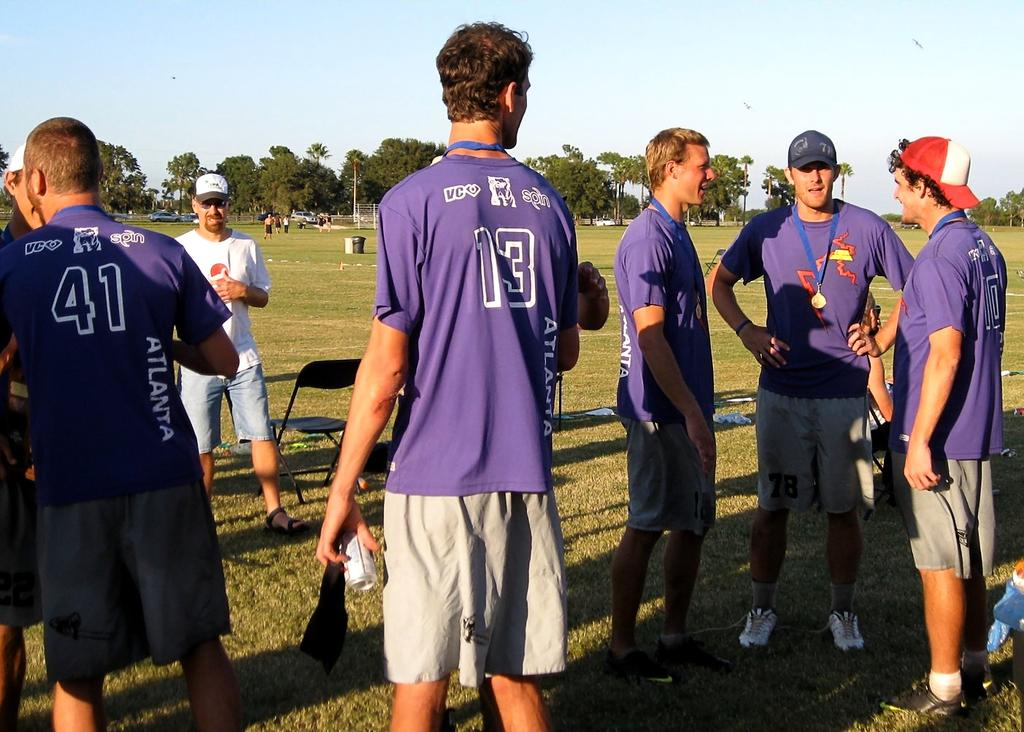<image>
Create a compact narrative representing the image presented. Several young men stand around conversating all wearing the same shirts one with the number forty one embroidered on his shirt. 